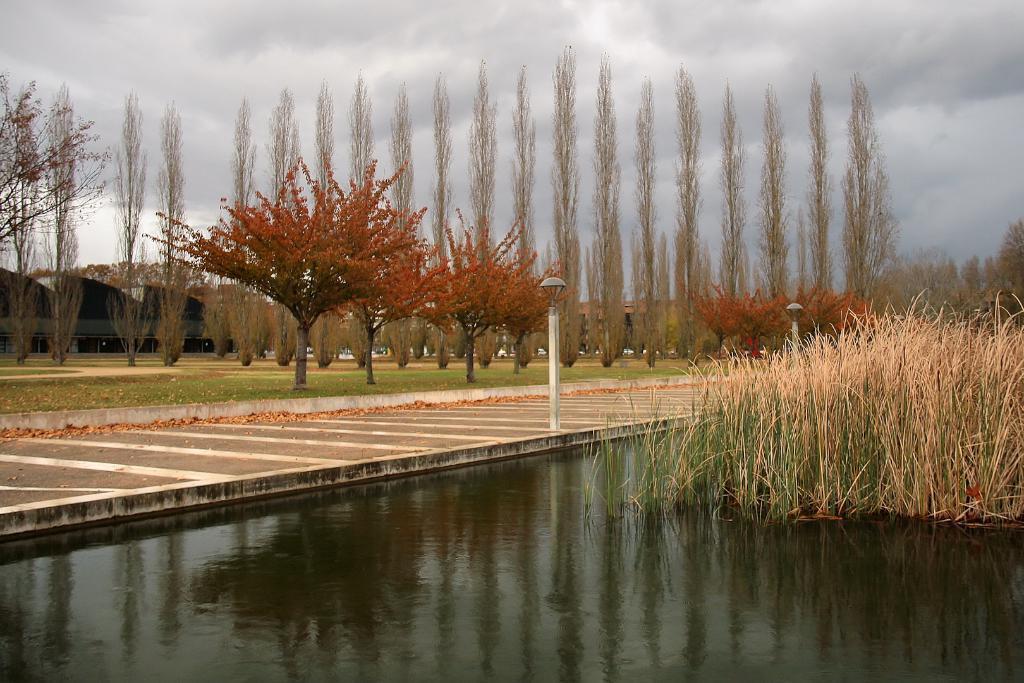Describe this image in one or two sentences. In the background we can see the sky. In this picture we can see the trees, shed, poles, lights, green grass. We can see the dried leaves on the road. On the right side of the picture we can see the water and plants. 